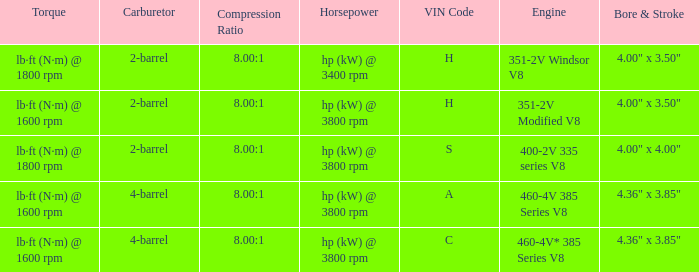What are the bore & stroke specifications for an engine with 4-barrel carburetor and VIN code of A? 4.36" x 3.85". 